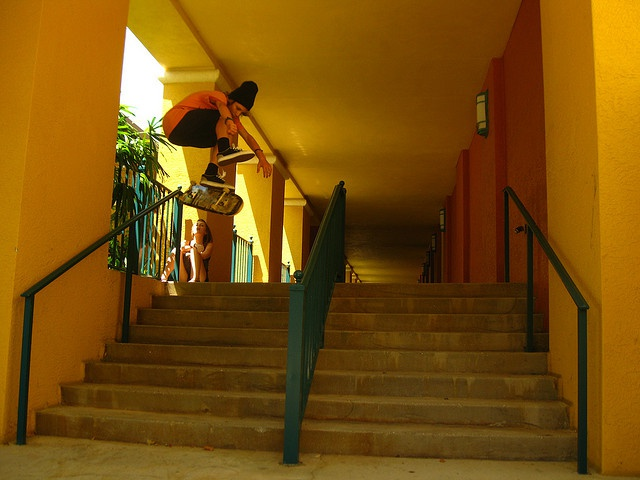Describe the objects in this image and their specific colors. I can see people in olive, black, brown, and maroon tones, people in olive, brown, maroon, black, and white tones, and skateboard in olive, maroon, and black tones in this image. 